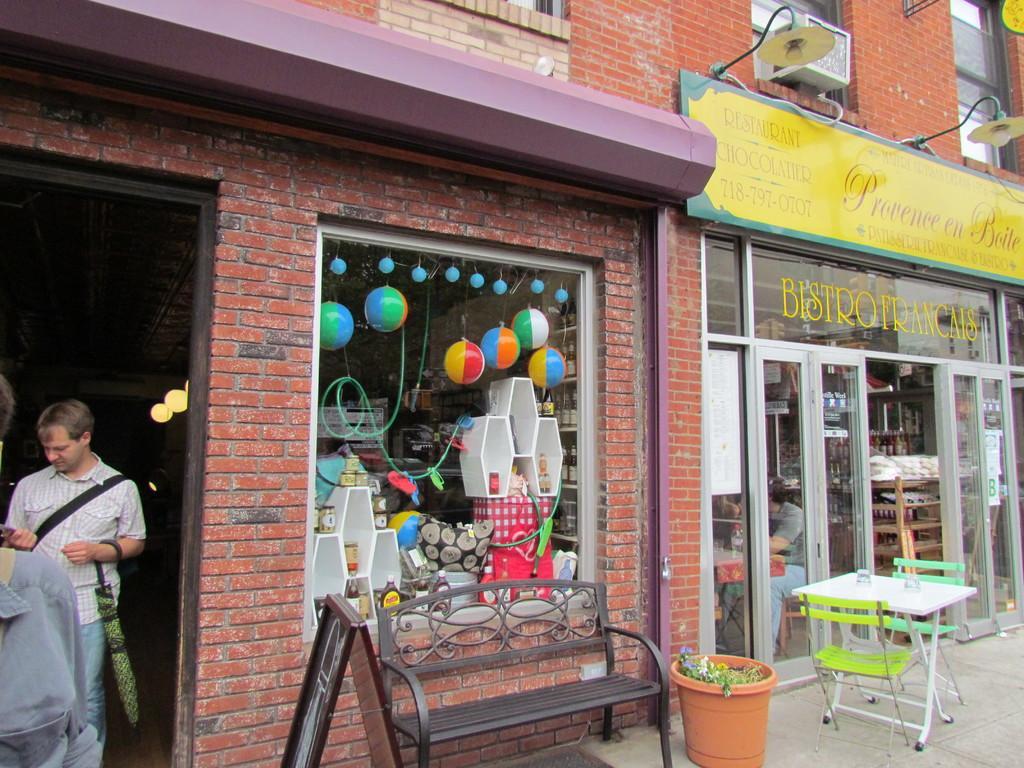Please provide a concise description of this image. This looks like a toy shop. There is a man on the left side holding a umbrella in his left hand. There is another shop on the right side and this is table and a chair arrangement on the outside of a shop. 